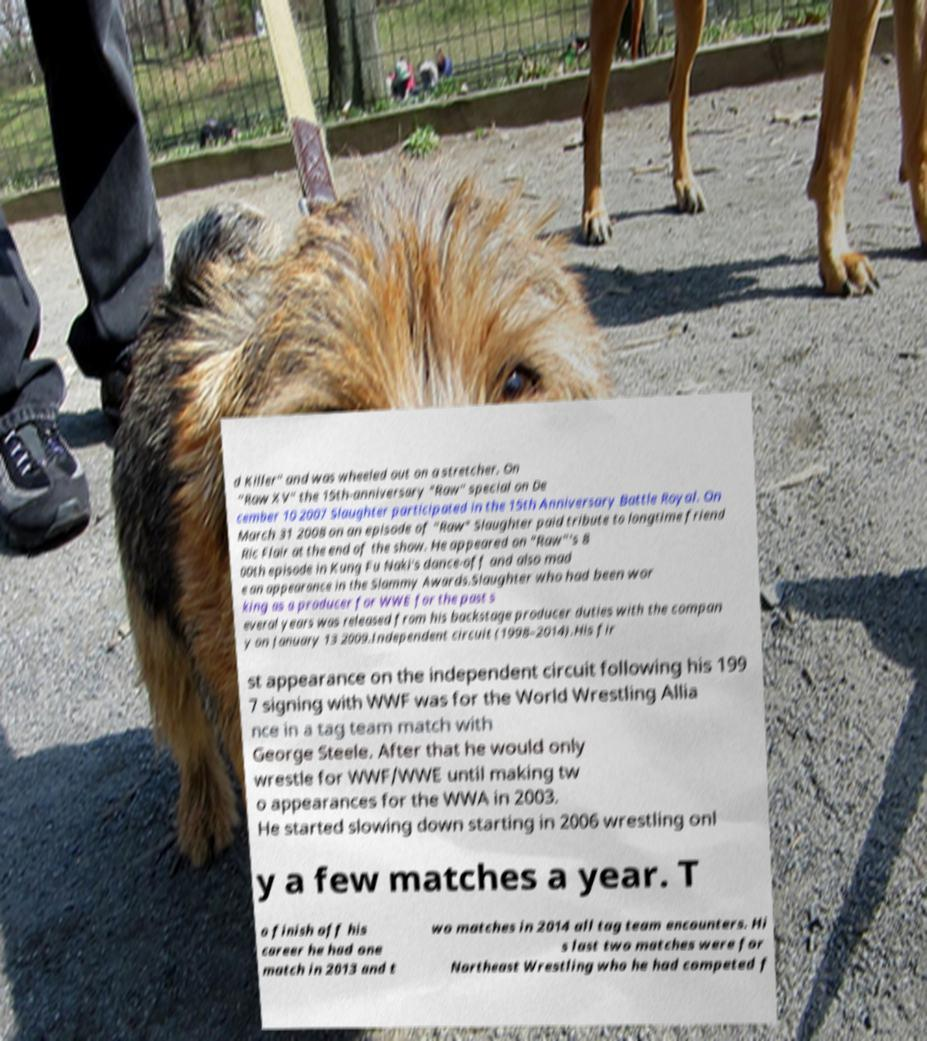Could you assist in decoding the text presented in this image and type it out clearly? d Killer" and was wheeled out on a stretcher. On "Raw XV" the 15th-anniversary "Raw" special on De cember 10 2007 Slaughter participated in the 15th Anniversary Battle Royal. On March 31 2008 on an episode of "Raw" Slaughter paid tribute to longtime friend Ric Flair at the end of the show. He appeared on "Raw"'s 8 00th episode in Kung Fu Naki's dance-off and also mad e an appearance in the Slammy Awards.Slaughter who had been wor king as a producer for WWE for the past s everal years was released from his backstage producer duties with the compan y on January 13 2009.Independent circuit (1998–2014).His fir st appearance on the independent circuit following his 199 7 signing with WWF was for the World Wrestling Allia nce in a tag team match with George Steele. After that he would only wrestle for WWF/WWE until making tw o appearances for the WWA in 2003. He started slowing down starting in 2006 wrestling onl y a few matches a year. T o finish off his career he had one match in 2013 and t wo matches in 2014 all tag team encounters. Hi s last two matches were for Northeast Wrestling who he had competed f 